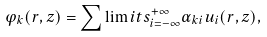Convert formula to latex. <formula><loc_0><loc_0><loc_500><loc_500>\varphi _ { k } ( r , z ) = \sum \lim i t s _ { i = - \infty } ^ { + \infty } \alpha _ { k i } u _ { i } ( r , z ) ,</formula> 